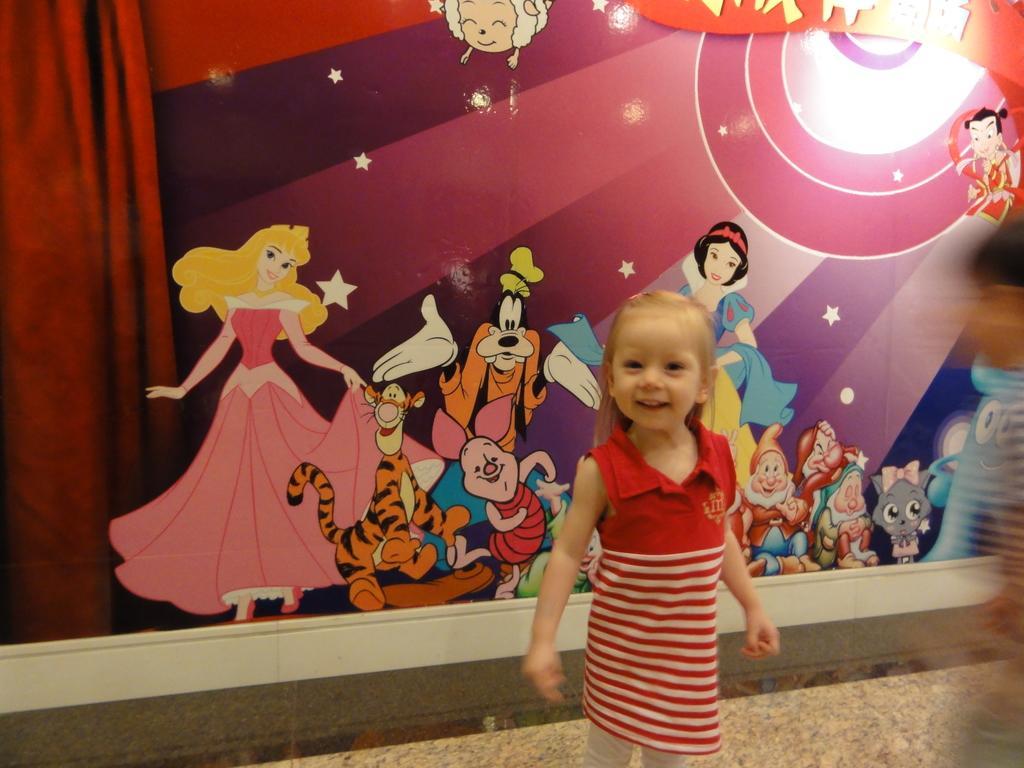In one or two sentences, can you explain what this image depicts? In this image, we can see a kid standing, in the background, we can see a poster. There is a curtain on the left side. 